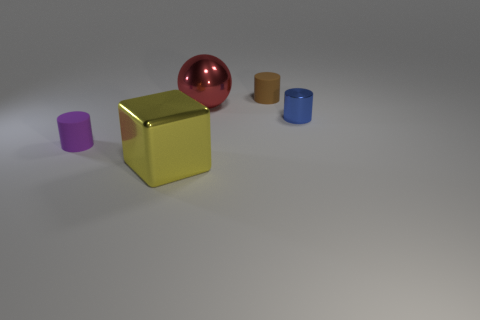What could the arrangement of objects tell us about the use of space in composition? The arrangement of objects creates a balanced composition using negative space effectively. The staggered placement of the objects leads the eye from the foreground rubber cylinder, to the metallic cube, and finally towards the metallic sphere at the back. This arrangement could be suggesting a sense of depth and perspective, as the objects vary in size and are strategically placed to create a visual pathway or narrative. 